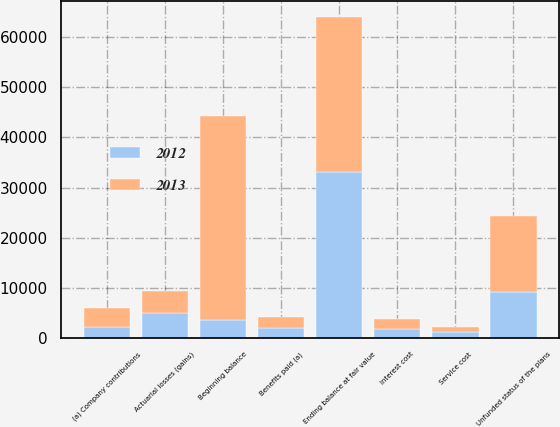<chart> <loc_0><loc_0><loc_500><loc_500><stacked_bar_chart><ecel><fcel>Beginning balance<fcel>Service cost<fcel>Interest cost<fcel>Benefits paid (a)<fcel>Actuarial losses (gains)<fcel>(a) Company contributions<fcel>Ending balance at fair value<fcel>Unfunded status of the plans<nl><fcel>2012<fcel>3637<fcel>1142<fcel>1800<fcel>2023<fcel>4882<fcel>2250<fcel>33010<fcel>9151<nl><fcel>2013<fcel>40616<fcel>1055<fcel>1884<fcel>2094<fcel>4442<fcel>3637<fcel>30924<fcel>15093<nl></chart> 